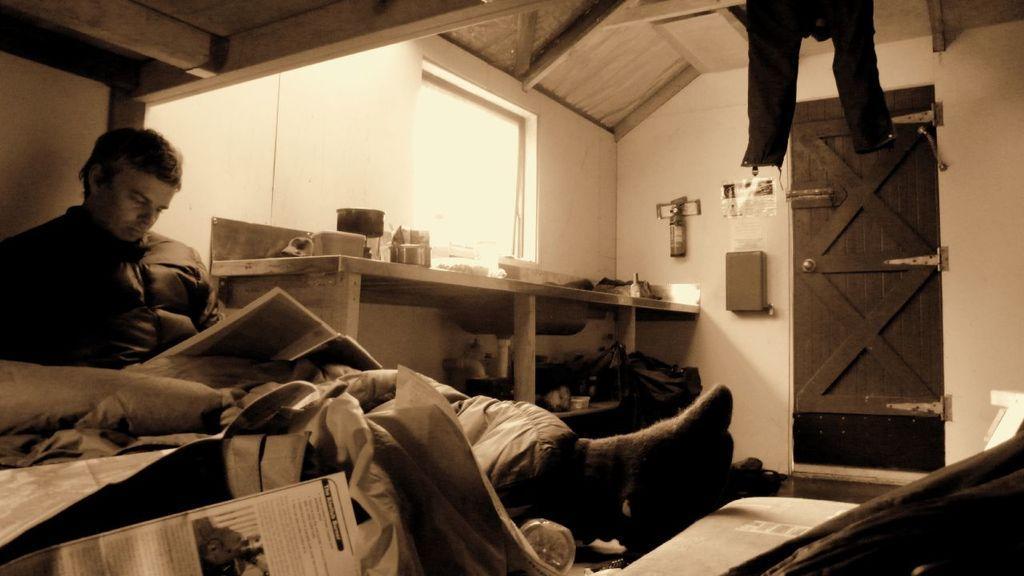Can you describe this image briefly? In this image we can see this person wearing a jacket is sitting on the bed and holding a book in his hands. Here we can see the blanket, papers and the bottle on the bed. In the background, we can see bowls, sink and a few things here, we can see pant hanged here, we can see wooden door, glass windows and wooden ceiling. Here we can see a few things on the wall. 